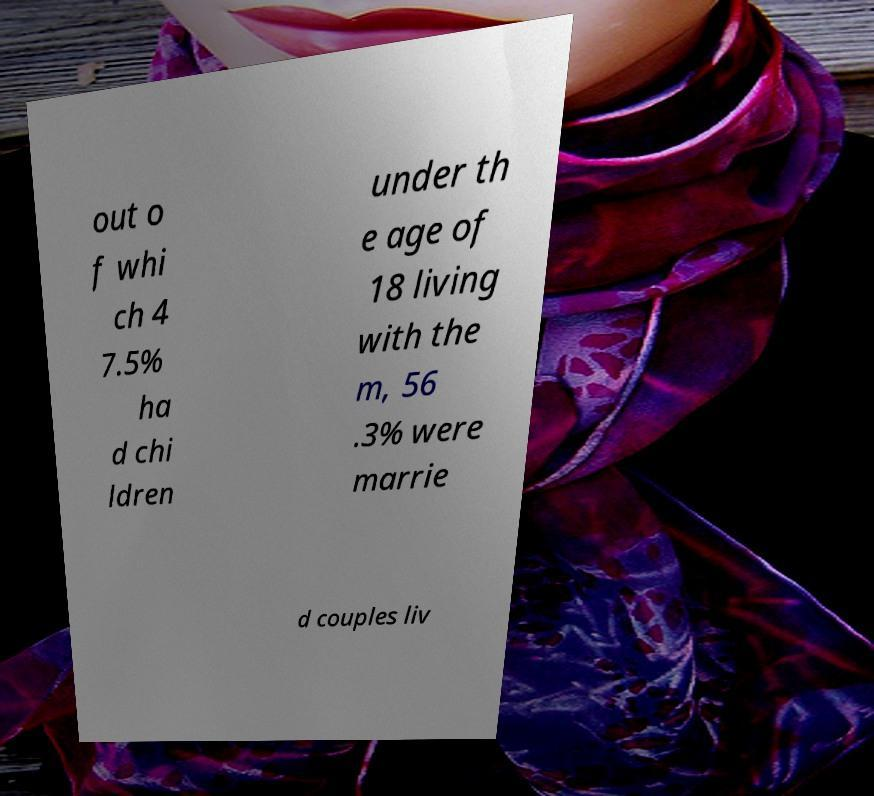Please identify and transcribe the text found in this image. out o f whi ch 4 7.5% ha d chi ldren under th e age of 18 living with the m, 56 .3% were marrie d couples liv 